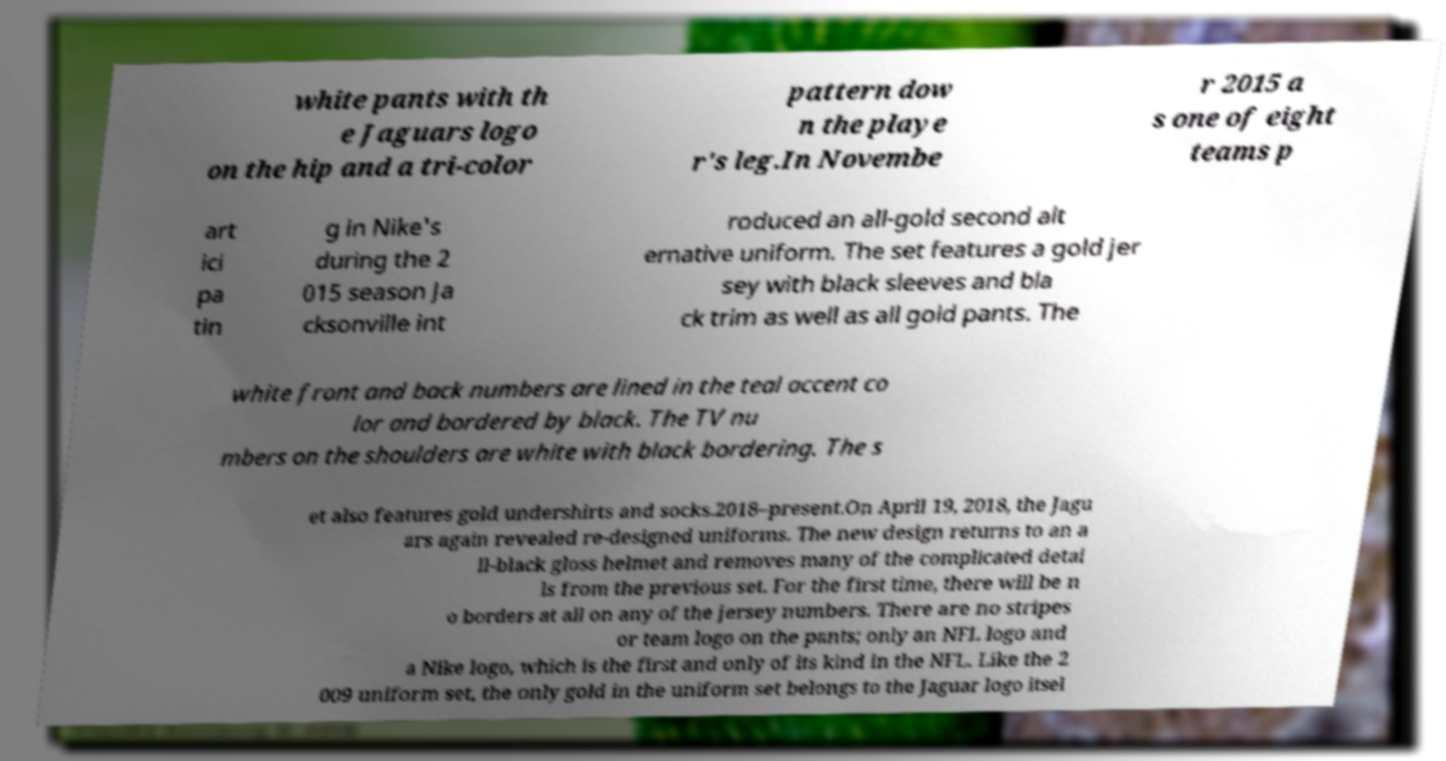For documentation purposes, I need the text within this image transcribed. Could you provide that? white pants with th e Jaguars logo on the hip and a tri-color pattern dow n the playe r's leg.In Novembe r 2015 a s one of eight teams p art ici pa tin g in Nike's during the 2 015 season Ja cksonville int roduced an all-gold second alt ernative uniform. The set features a gold jer sey with black sleeves and bla ck trim as well as all gold pants. The white front and back numbers are lined in the teal accent co lor and bordered by black. The TV nu mbers on the shoulders are white with black bordering. The s et also features gold undershirts and socks.2018–present.On April 19, 2018, the Jagu ars again revealed re-designed uniforms. The new design returns to an a ll-black gloss helmet and removes many of the complicated detai ls from the previous set. For the first time, there will be n o borders at all on any of the jersey numbers. There are no stripes or team logo on the pants; only an NFL logo and a Nike logo, which is the first and only of its kind in the NFL. Like the 2 009 uniform set, the only gold in the uniform set belongs to the Jaguar logo itsel 